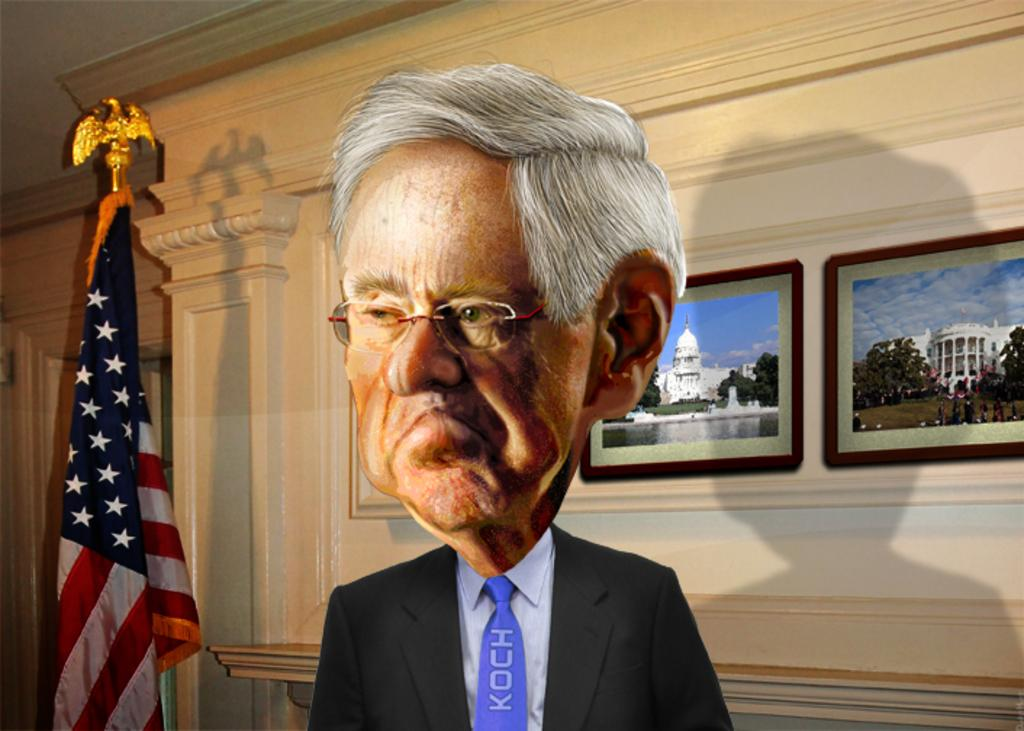What is the main subject of the image? There is a man standing in the image. Where is the flag located in the image? The flag is on the left side of the image. What can be seen in the background of the image? There is a wall in the background of the image. What is hanging on the wall? There are photo frames on the wall. Can you tell me how many horses are grazing in the cemetery in the image? There is no cemetery or horses present in the image; it features a man, a flag, a wall, and photo frames. 